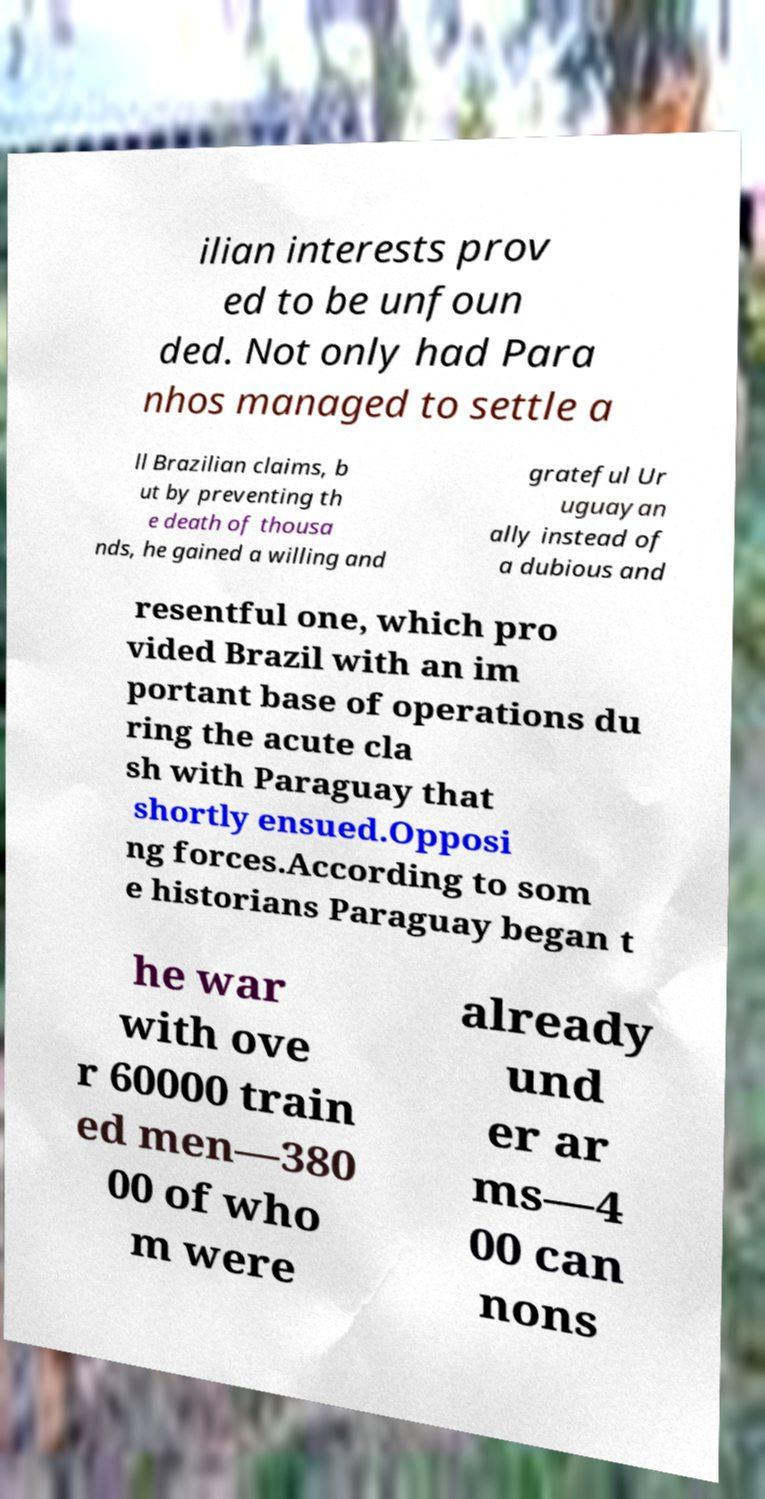There's text embedded in this image that I need extracted. Can you transcribe it verbatim? ilian interests prov ed to be unfoun ded. Not only had Para nhos managed to settle a ll Brazilian claims, b ut by preventing th e death of thousa nds, he gained a willing and grateful Ur uguayan ally instead of a dubious and resentful one, which pro vided Brazil with an im portant base of operations du ring the acute cla sh with Paraguay that shortly ensued.Opposi ng forces.According to som e historians Paraguay began t he war with ove r 60000 train ed men—380 00 of who m were already und er ar ms—4 00 can nons 